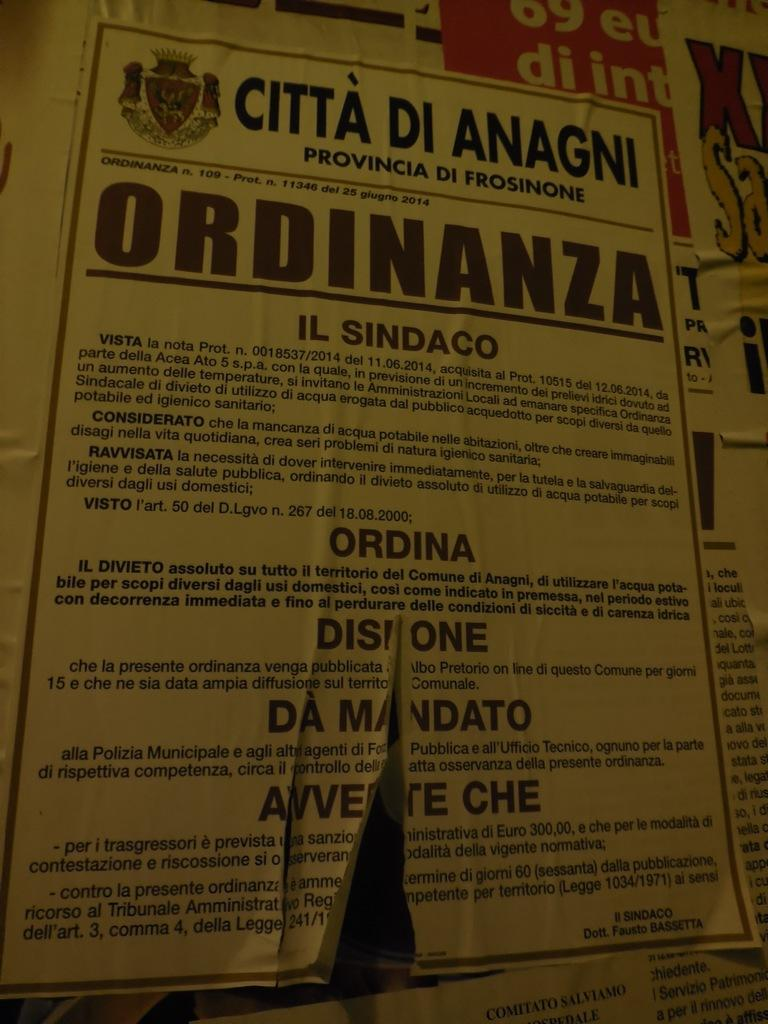<image>
Provide a brief description of the given image. A yellow poster that starts with "Citta di Anagni." 